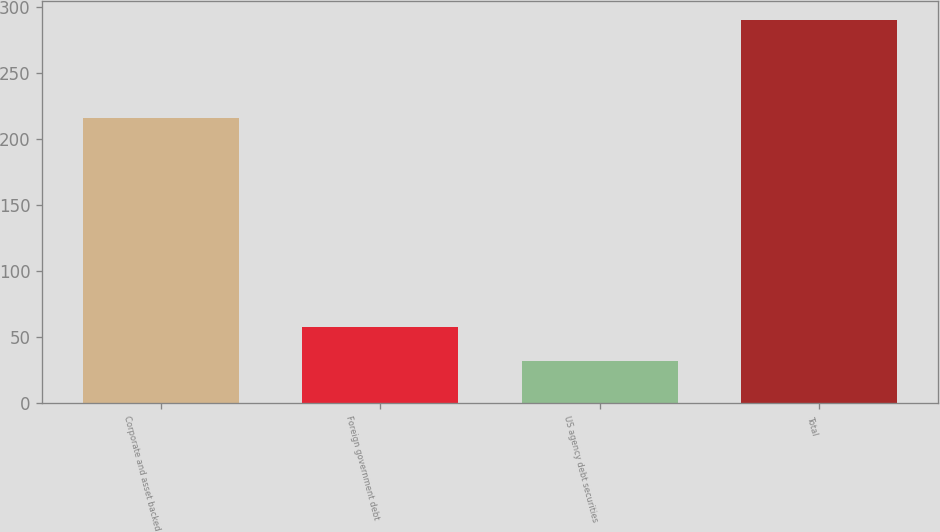<chart> <loc_0><loc_0><loc_500><loc_500><bar_chart><fcel>Corporate and asset backed<fcel>Foreign government debt<fcel>US agency debt securities<fcel>Total<nl><fcel>216<fcel>57.8<fcel>32<fcel>290<nl></chart> 